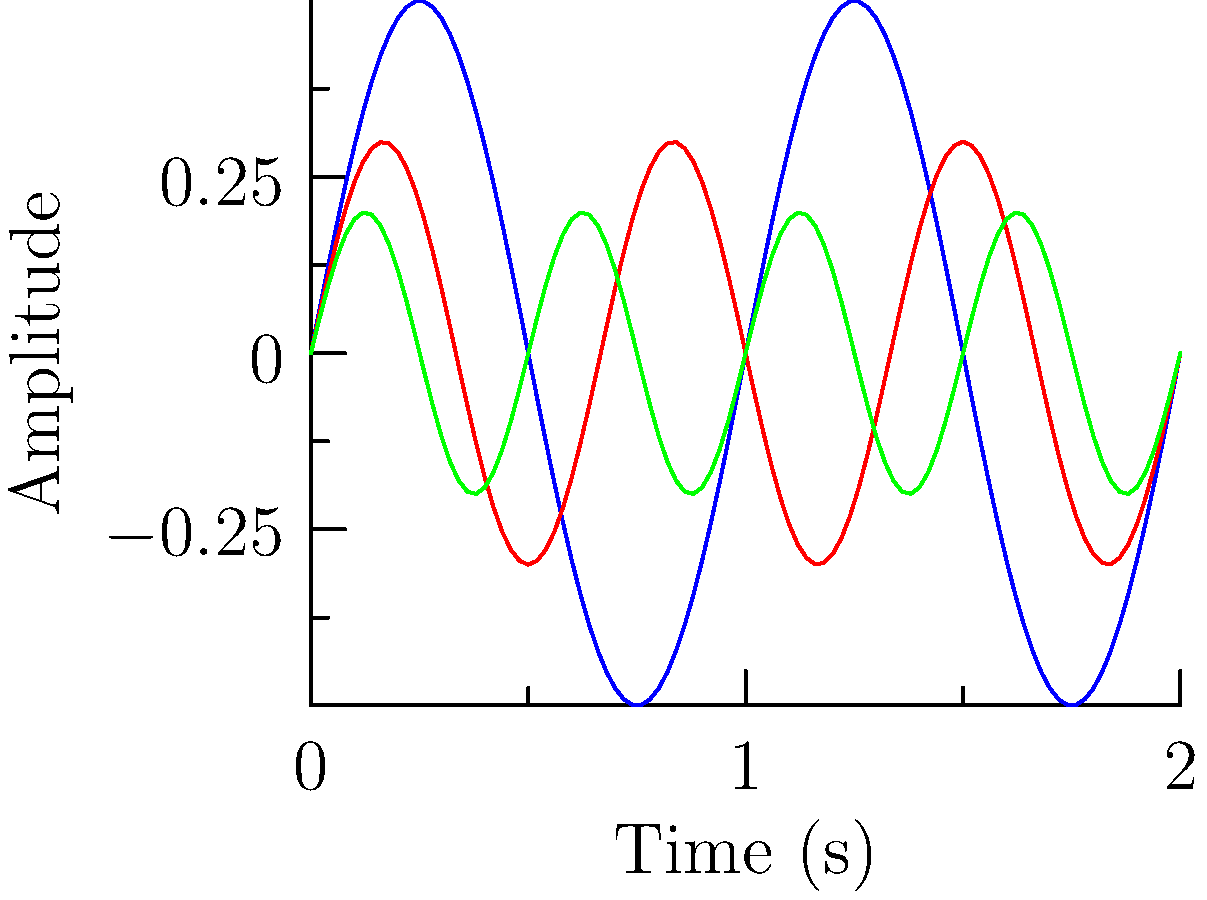Given the frequency spectrum of three musical instruments represented by overlapping wave functions, calculate the area between the violin and flute curves over one complete cycle. How might this quantitative approach impact the emotional perception of these instruments' timbres? To solve this problem, we'll follow these steps:

1) The wave functions for the violin and flute are:
   Violin: $f_1(x) = 0.5\sin(2\pi x)$
   Flute: $f_2(x) = 0.3\sin(3\pi x)$

2) The area between the curves is given by the integral of their absolute difference:
   $A = \int_0^T |f_1(x) - f_2(x)| dx$
   where $T$ is the period of one complete cycle.

3) The period $T$ is the least common multiple of the individual periods:
   $T_1 = 1$ for violin, $T_2 = \frac{2}{3}$ for flute
   $T = LCM(1, \frac{2}{3}) = 2$

4) Set up the integral:
   $A = \int_0^2 |0.5\sin(2\pi x) - 0.3\sin(3\pi x)| dx$

5) This integral is complex to solve analytically. Numerical integration methods would typically be used.

6) The result of this integration would give us a quantitative measure of the difference between the timbres of the violin and flute.

7) However, this numerical approach doesn't capture the emotional nuances of how we perceive these instruments. The timbre, which this calculation attempts to quantify, is just one aspect of the complex emotional response to music.

8) While this calculation provides a mathematical representation of the difference in sound waves, it doesn't account for cultural associations, personal experiences, or the context in which the instruments are played - all crucial factors in the emotional connection to music.
Answer: The area cannot be easily calculated analytically. Numerical methods are required, which exemplifies the limitation of purely quantitative approaches in capturing the emotional essence of music. 